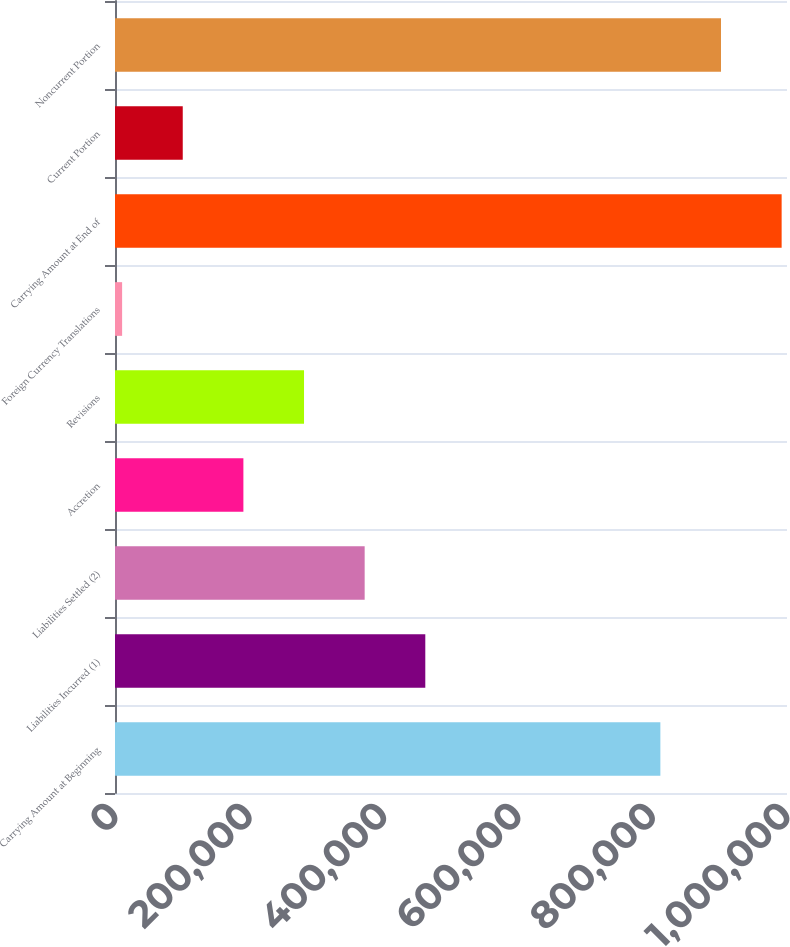Convert chart to OTSL. <chart><loc_0><loc_0><loc_500><loc_500><bar_chart><fcel>Carrying Amount at Beginning<fcel>Liabilities Incurred (1)<fcel>Liabilities Settled (2)<fcel>Accretion<fcel>Revisions<fcel>Foreign Currency Translations<fcel>Carrying Amount at End of<fcel>Current Portion<fcel>Noncurrent Portion<nl><fcel>811554<fcel>461756<fcel>371523<fcel>191055<fcel>281289<fcel>10587<fcel>992022<fcel>100821<fcel>901788<nl></chart> 